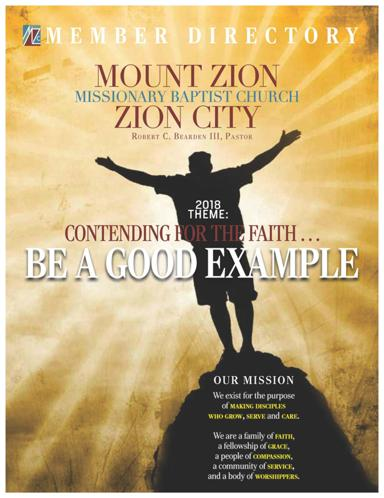What is the name of the church mentioned in the image? The name of the church is Mount Zion Missionary Baptist Church in Zion City. Who is the pastor of the church? The pastor of the church is Robert C. Bearden III. What is the mission of the church? The mission of the church is to exist for the purpose of strengthening those who grow, serve, and care. The church emphasizes being a family, a fellowship, a people of compassion, a community of service, and a body of worshippers. 